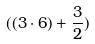Convert formula to latex. <formula><loc_0><loc_0><loc_500><loc_500>( ( 3 \cdot 6 ) + \frac { 3 } { 2 } )</formula> 